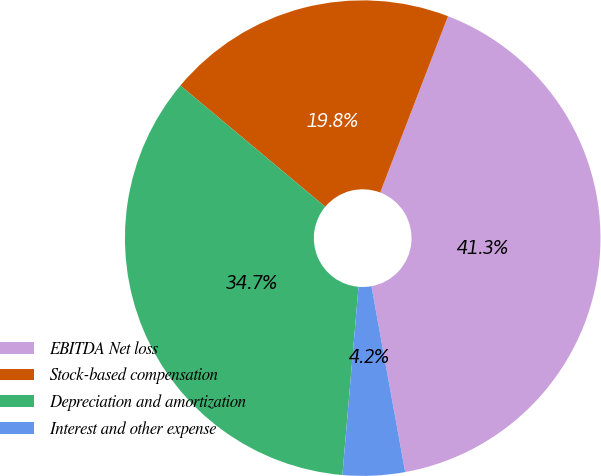Convert chart to OTSL. <chart><loc_0><loc_0><loc_500><loc_500><pie_chart><fcel>EBITDA Net loss<fcel>Stock-based compensation<fcel>Depreciation and amortization<fcel>Interest and other expense<nl><fcel>41.3%<fcel>19.75%<fcel>34.73%<fcel>4.22%<nl></chart> 